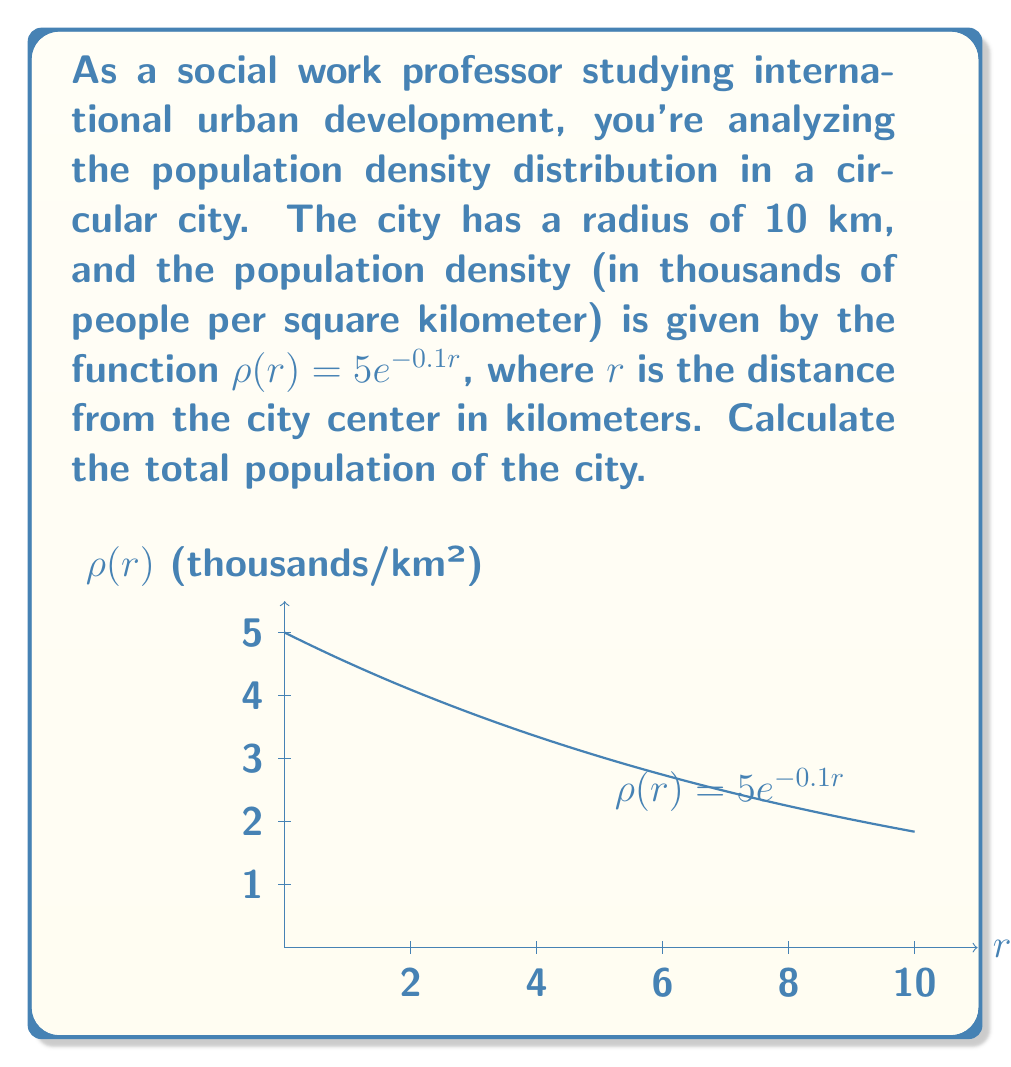Give your solution to this math problem. To solve this problem, we need to integrate the population density function over the entire circular area of the city. Here's a step-by-step approach:

1) In polar coordinates, the area element is given by $dA = r dr d\theta$.

2) The total population is the integral of the density function over the entire area:

   $$P = \int_0^{2\pi} \int_0^{10} \rho(r) \cdot r \, dr \, d\theta$$

3) Substitute the given density function:

   $$P = \int_0^{2\pi} \int_0^{10} 5e^{-0.1r} \cdot r \, dr \, d\theta$$

4) The integral is separable. The $\theta$ integral is simply $2\pi$, so we can simplify:

   $$P = 2\pi \int_0^{10} 5re^{-0.1r} \, dr$$

5) To solve this integral, we can use integration by parts. Let $u = r$ and $dv = 5e^{-0.1r} \, dr$. Then $du = dr$ and $v = -50e^{-0.1r}$. Applying the formula:

   $$P = 2\pi \left[-50re^{-0.1r}\right]_0^{10} - 2\pi \int_0^{10} -50e^{-0.1r} \, dr$$

6) Evaluating the first term and simplifying the second integral:

   $$P = 2\pi \left(-500e^{-1} + 0\right) + 100\pi \left[e^{-0.1r}\right]_0^{10}$$

7) Evaluating the remaining terms:

   $$P = -1000\pi e^{-1} + 100\pi(e^{-1} - 1)$$

8) Simplifying:

   $$P = 100\pi(1 - e^{-1}) \approx 204.7 \text{ thousand}$$
Answer: $100\pi(1 - e^{-1}) \approx 204,700$ people 